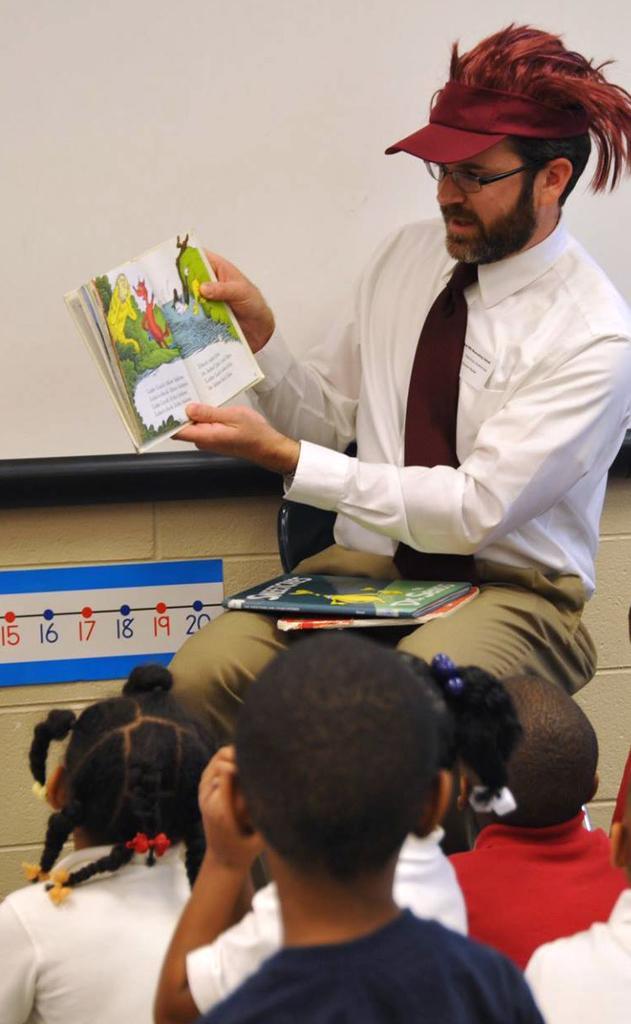Please provide a concise description of this image. In the foreground of the picture there are kids sitting. In the center of the picture there is a person holding books and wearing a cap. On the left there is a board. In the background it is projector screen. 